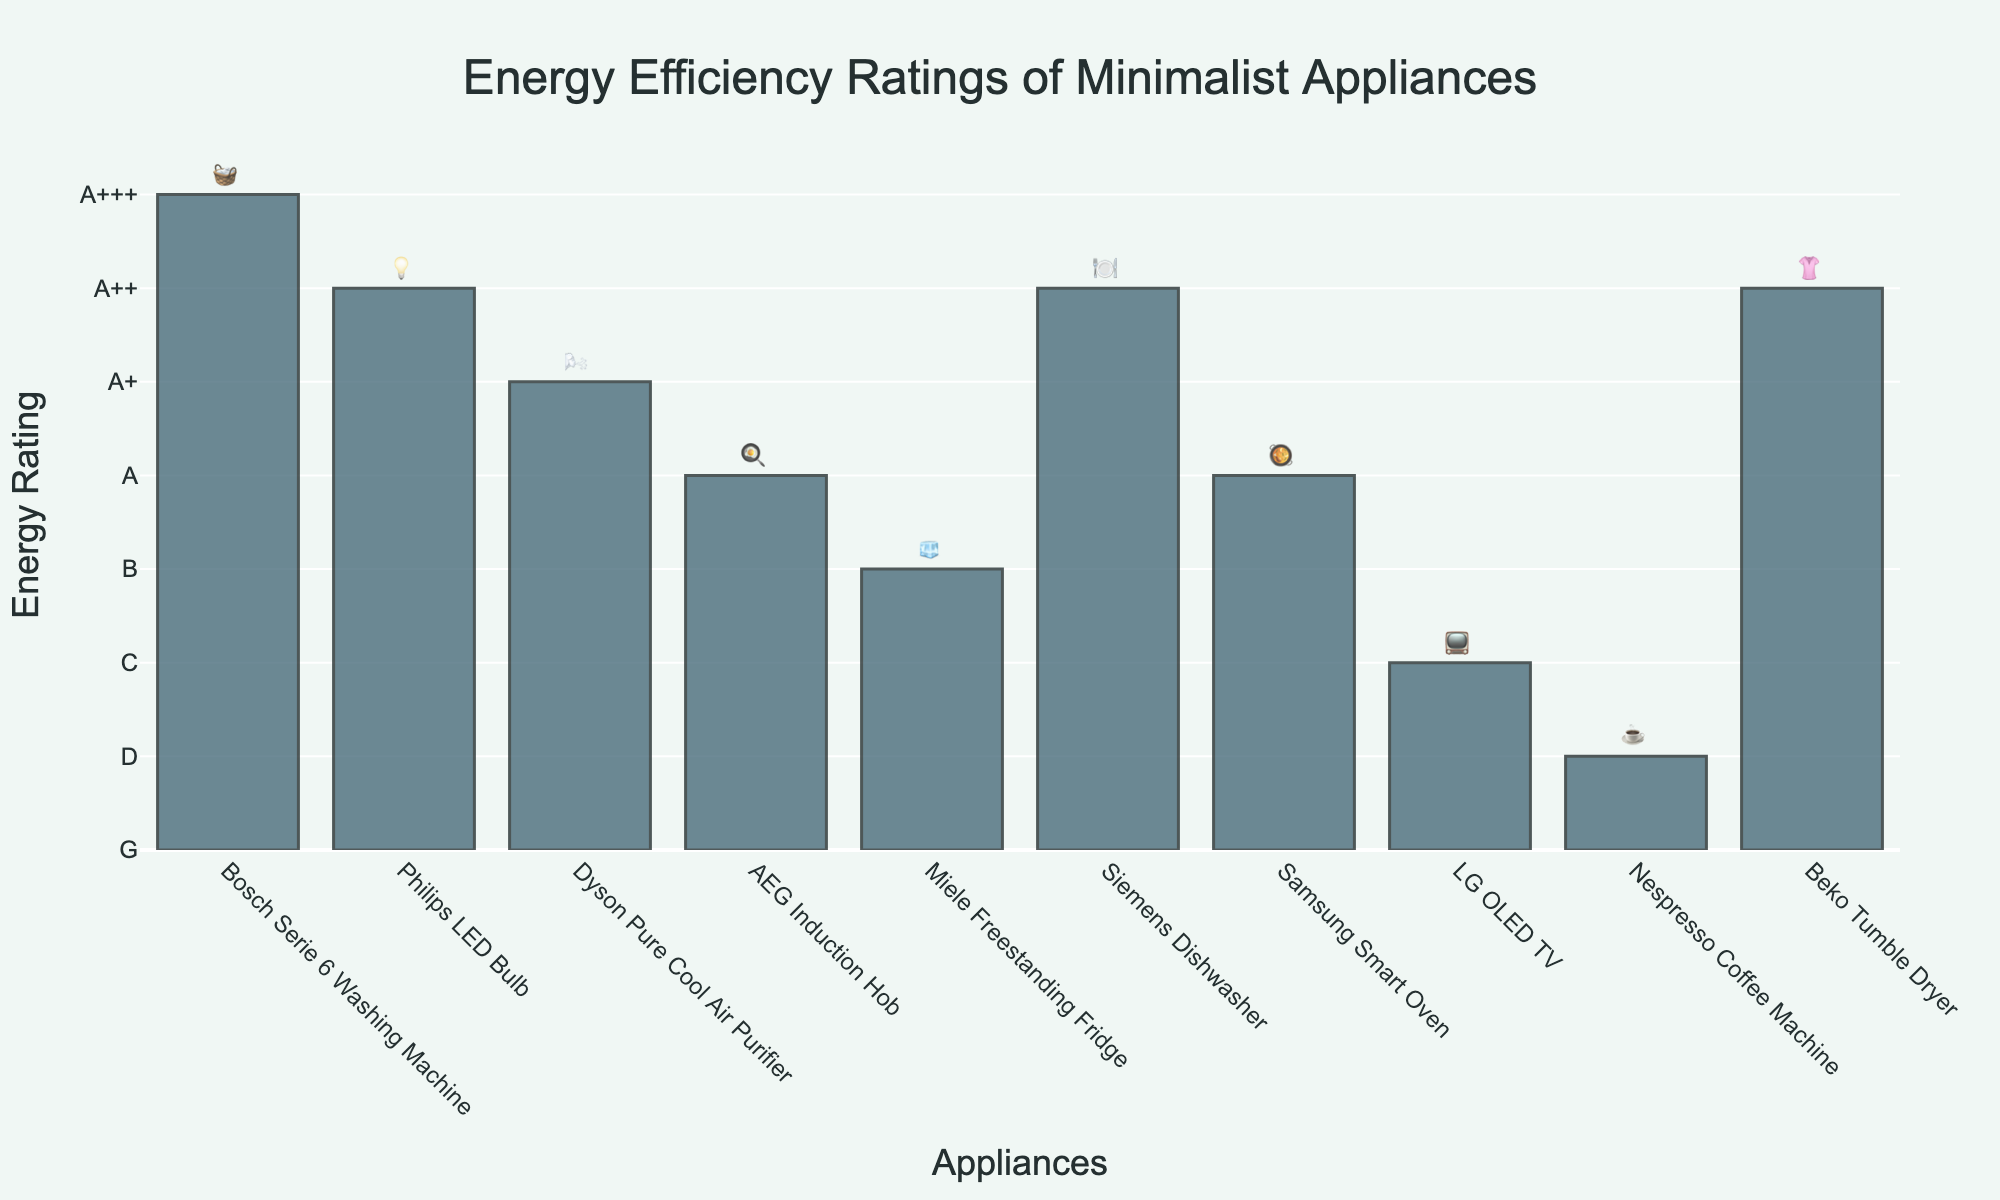what is the energy rating for the Bosch Serie 6 Washing Machine based on the figure? The Bosch Serie 6 Washing Machine is represented by the emoji 🧺, and the bar height indicates its energy rating, which is marked as A+++.
Answer: A+++ Which appliance has the lowest energy rating and what is its emoji? By looking at the bars and associated emojis, the Nespresso Coffee Machine (☕) has the lowest energy rating, indicated by the shortest bar with a rating of D.
Answer: Nespresso Coffee Machine, ☕ What is the difference in energy rating between the Beko Tumble Dryer and the LG OLED TV? The Beko Tumble Dryer has an energy rating of A++ (numeric value 6), and the LG OLED TV has an energy rating of C (numeric value 2). The difference is 6 - 2 = 4.
Answer: 4 How many appliances have an energy rating of A++? Looking at the bars for A++ ratings, four appliances (Philips LED Bulb, Siemens Dishwasher, Beko Tumble Dryer) with their respective emojis (💡, 🍽️, 👚) are present in the figure.
Answer: 3 Which appliances have a lower energy rating than the Samsung Smart Oven? The Samsung Smart Oven has an energy rating of A (numeric value 4). Appliances with lower ratings are Miele Freestanding Fridge (B, 3), LG OLED TV (C, 2), and Nespresso Coffee Machine (D, 1).
Answer: Miele Freestanding Fridge, LG OLED TV, Nespresso Coffee Machine What is the average energy rating of the appliances with emojis 🍳 and 🥘? AEG Induction Hob (🍳) has a rating of A and Samsung Smart Oven (🥘) has a rating of A. Both have a numeric value of 4. The average is (4 + 4) / 2 = 4.
Answer: 4 Which appliance represented by an emoji has the highest energy rating and what is that rating? The Bosch Serie 6 Washing Machine (🧺) has the highest energy rating, marked as A+++.
Answer: Bosch Serie 6 Washing Machine, A+++ 